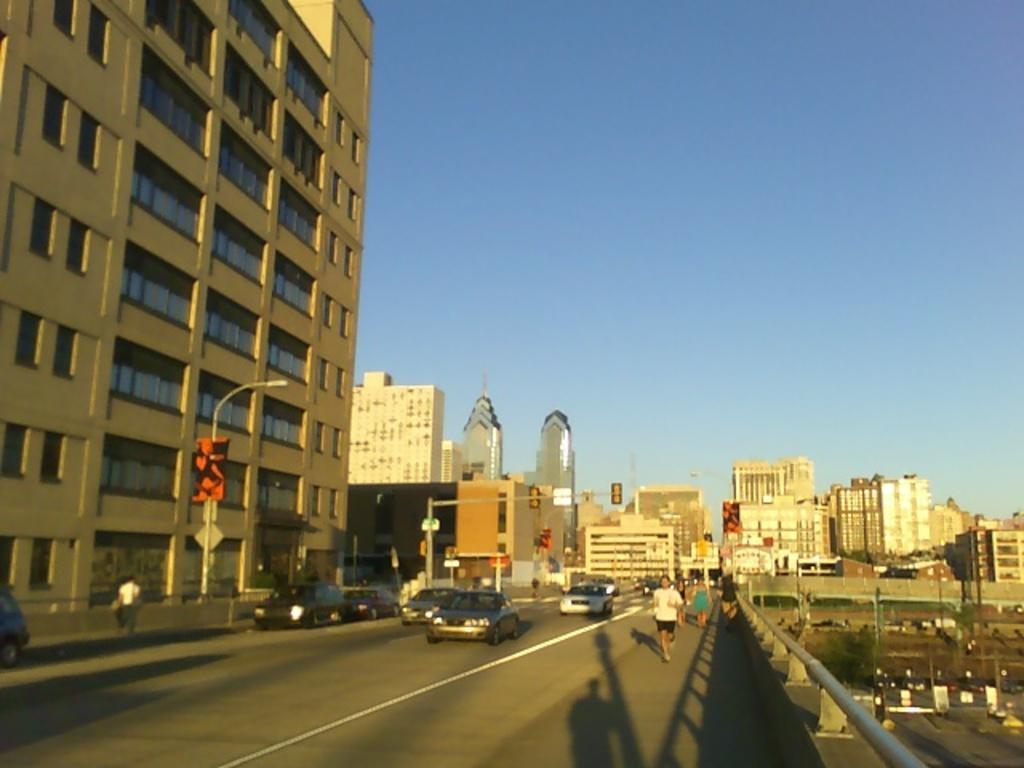What can be seen on the road in the image? There are vehicles and people on the road in the image. What else is present in the image besides the road? There are poles, boards, and buildings in the image. What is visible in the background of the image? The sky is visible in the background of the image. Is there a toy store visible in the image? There is no mention of a toy store in the image, and it cannot be determined from the provided facts. 